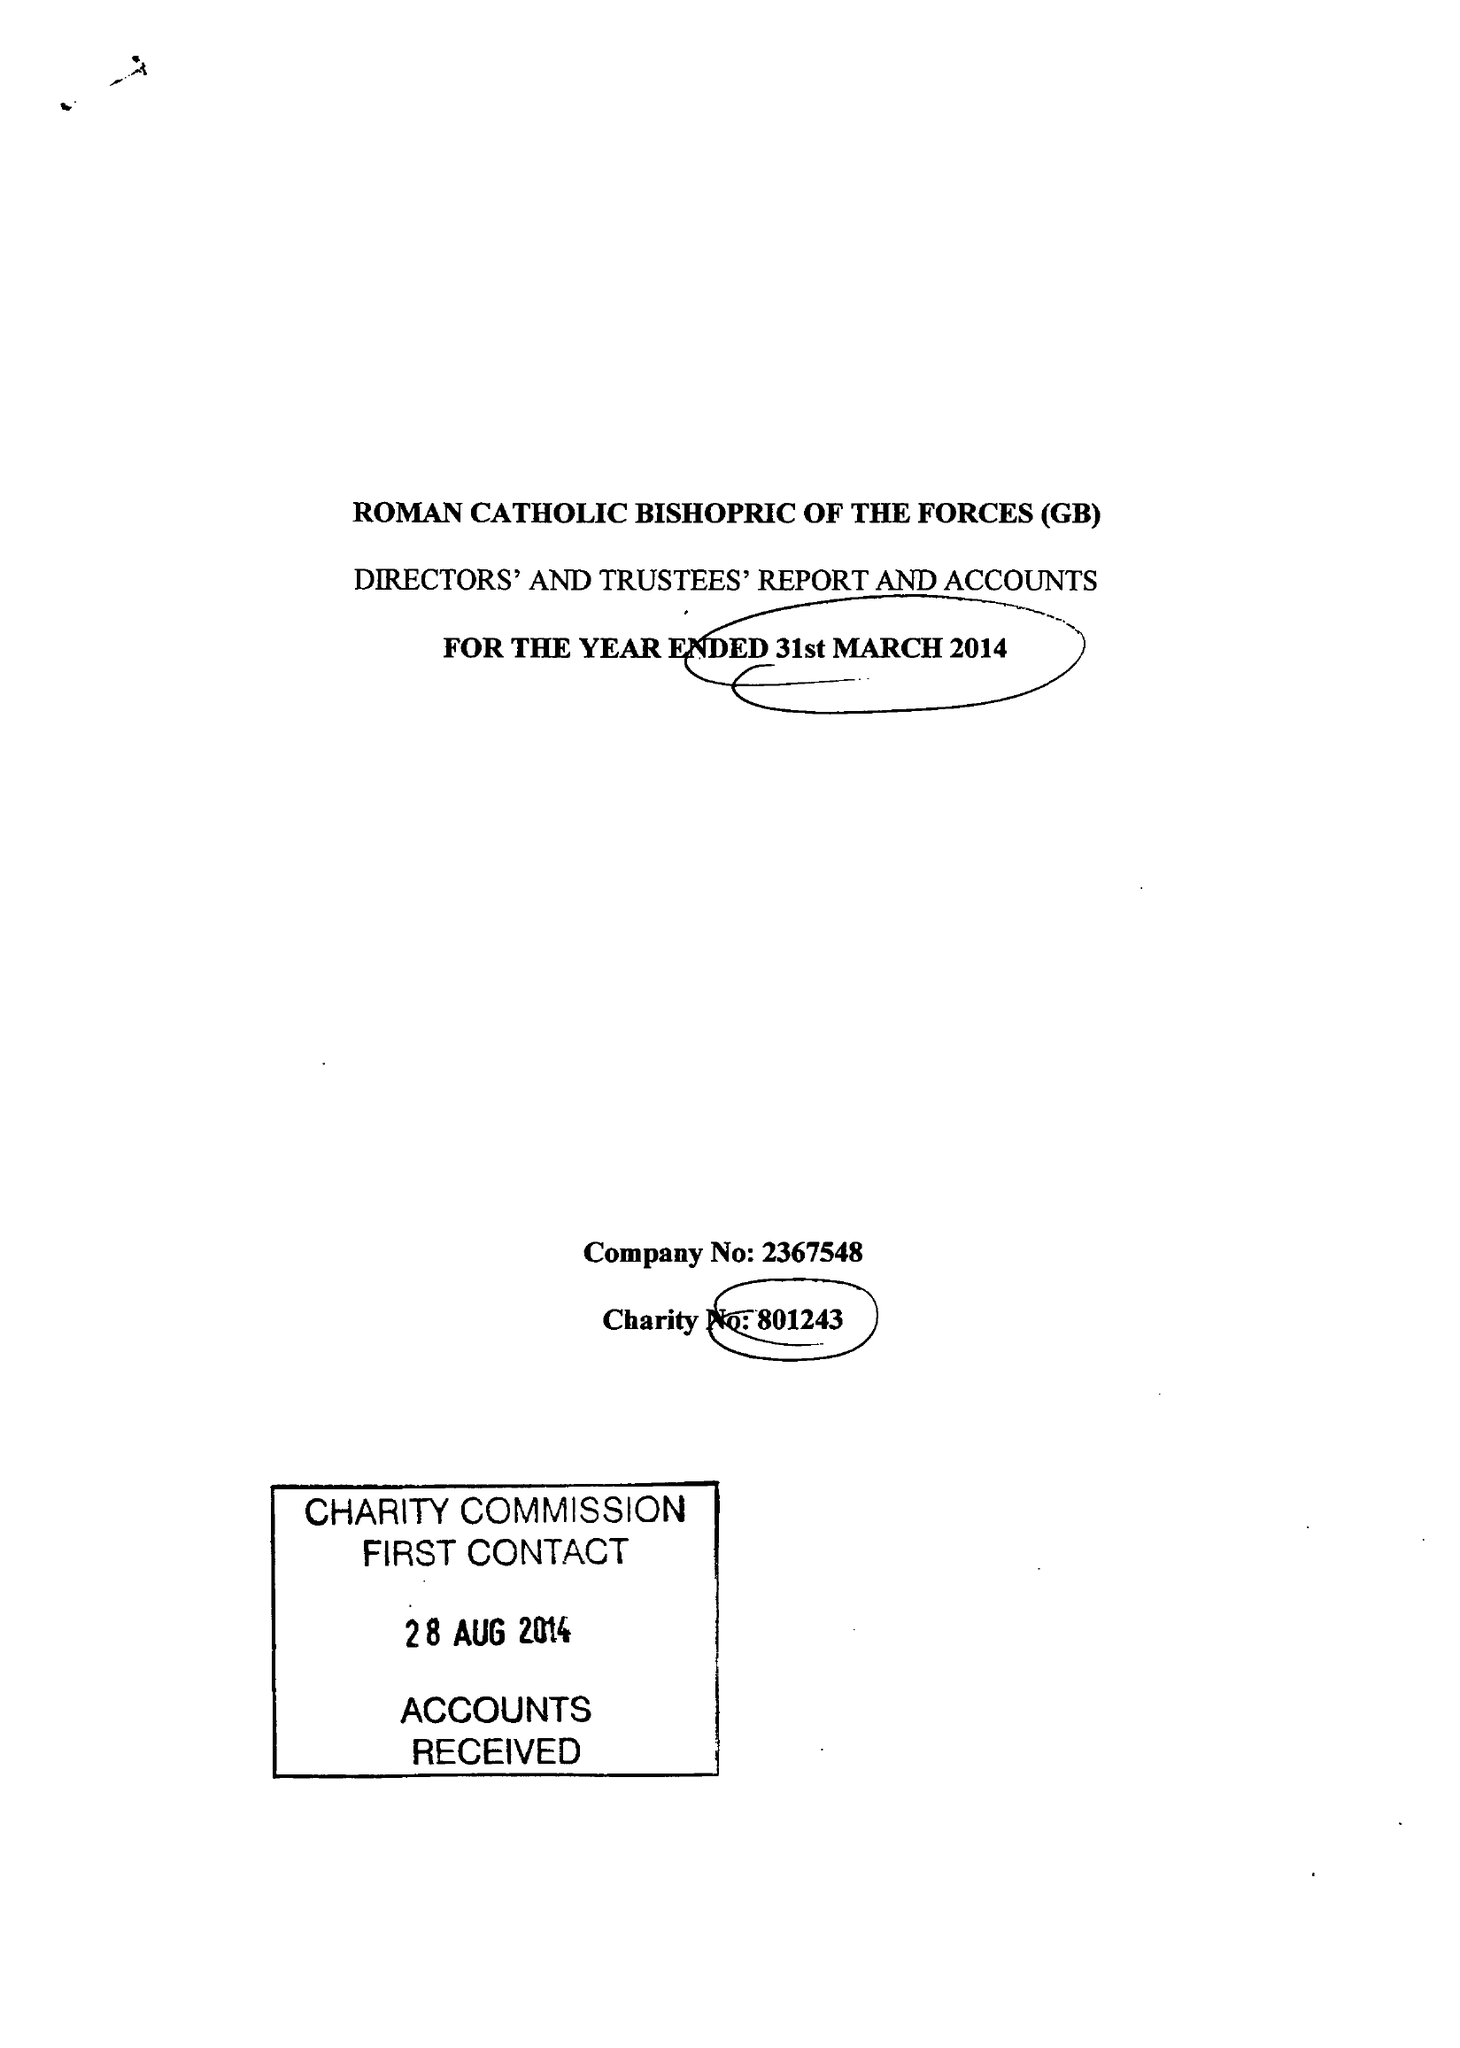What is the value for the address__post_town?
Answer the question using a single word or phrase. ALDERSHOT 